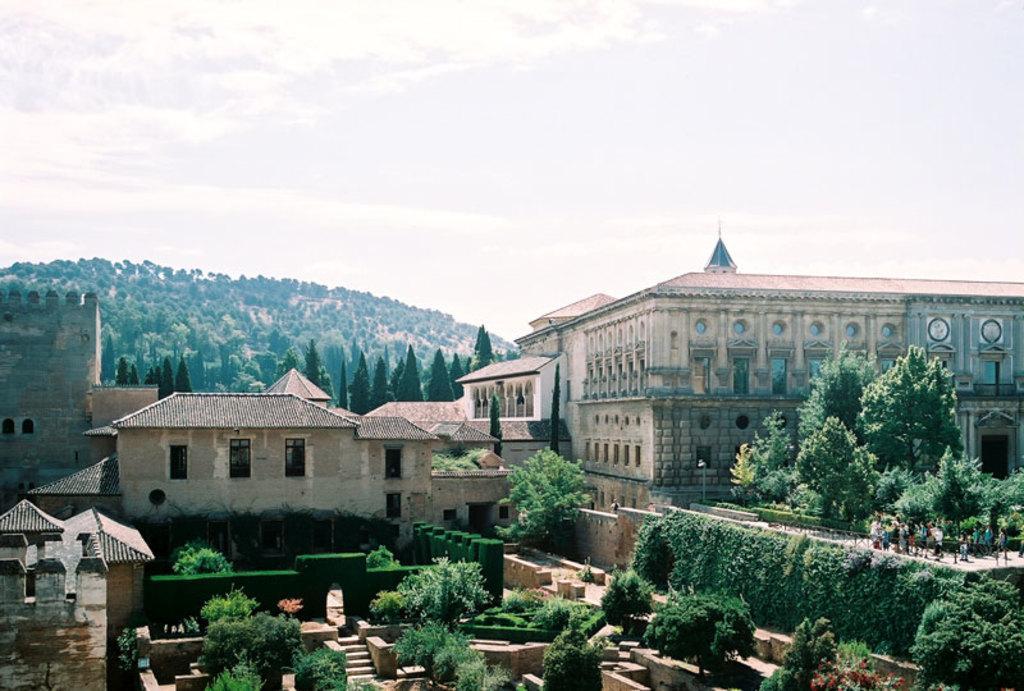Can you describe this image briefly? In the image there are buildings in the front with trees on either side of it and in the back there are hills covered with trees and above its sky with clouds. 